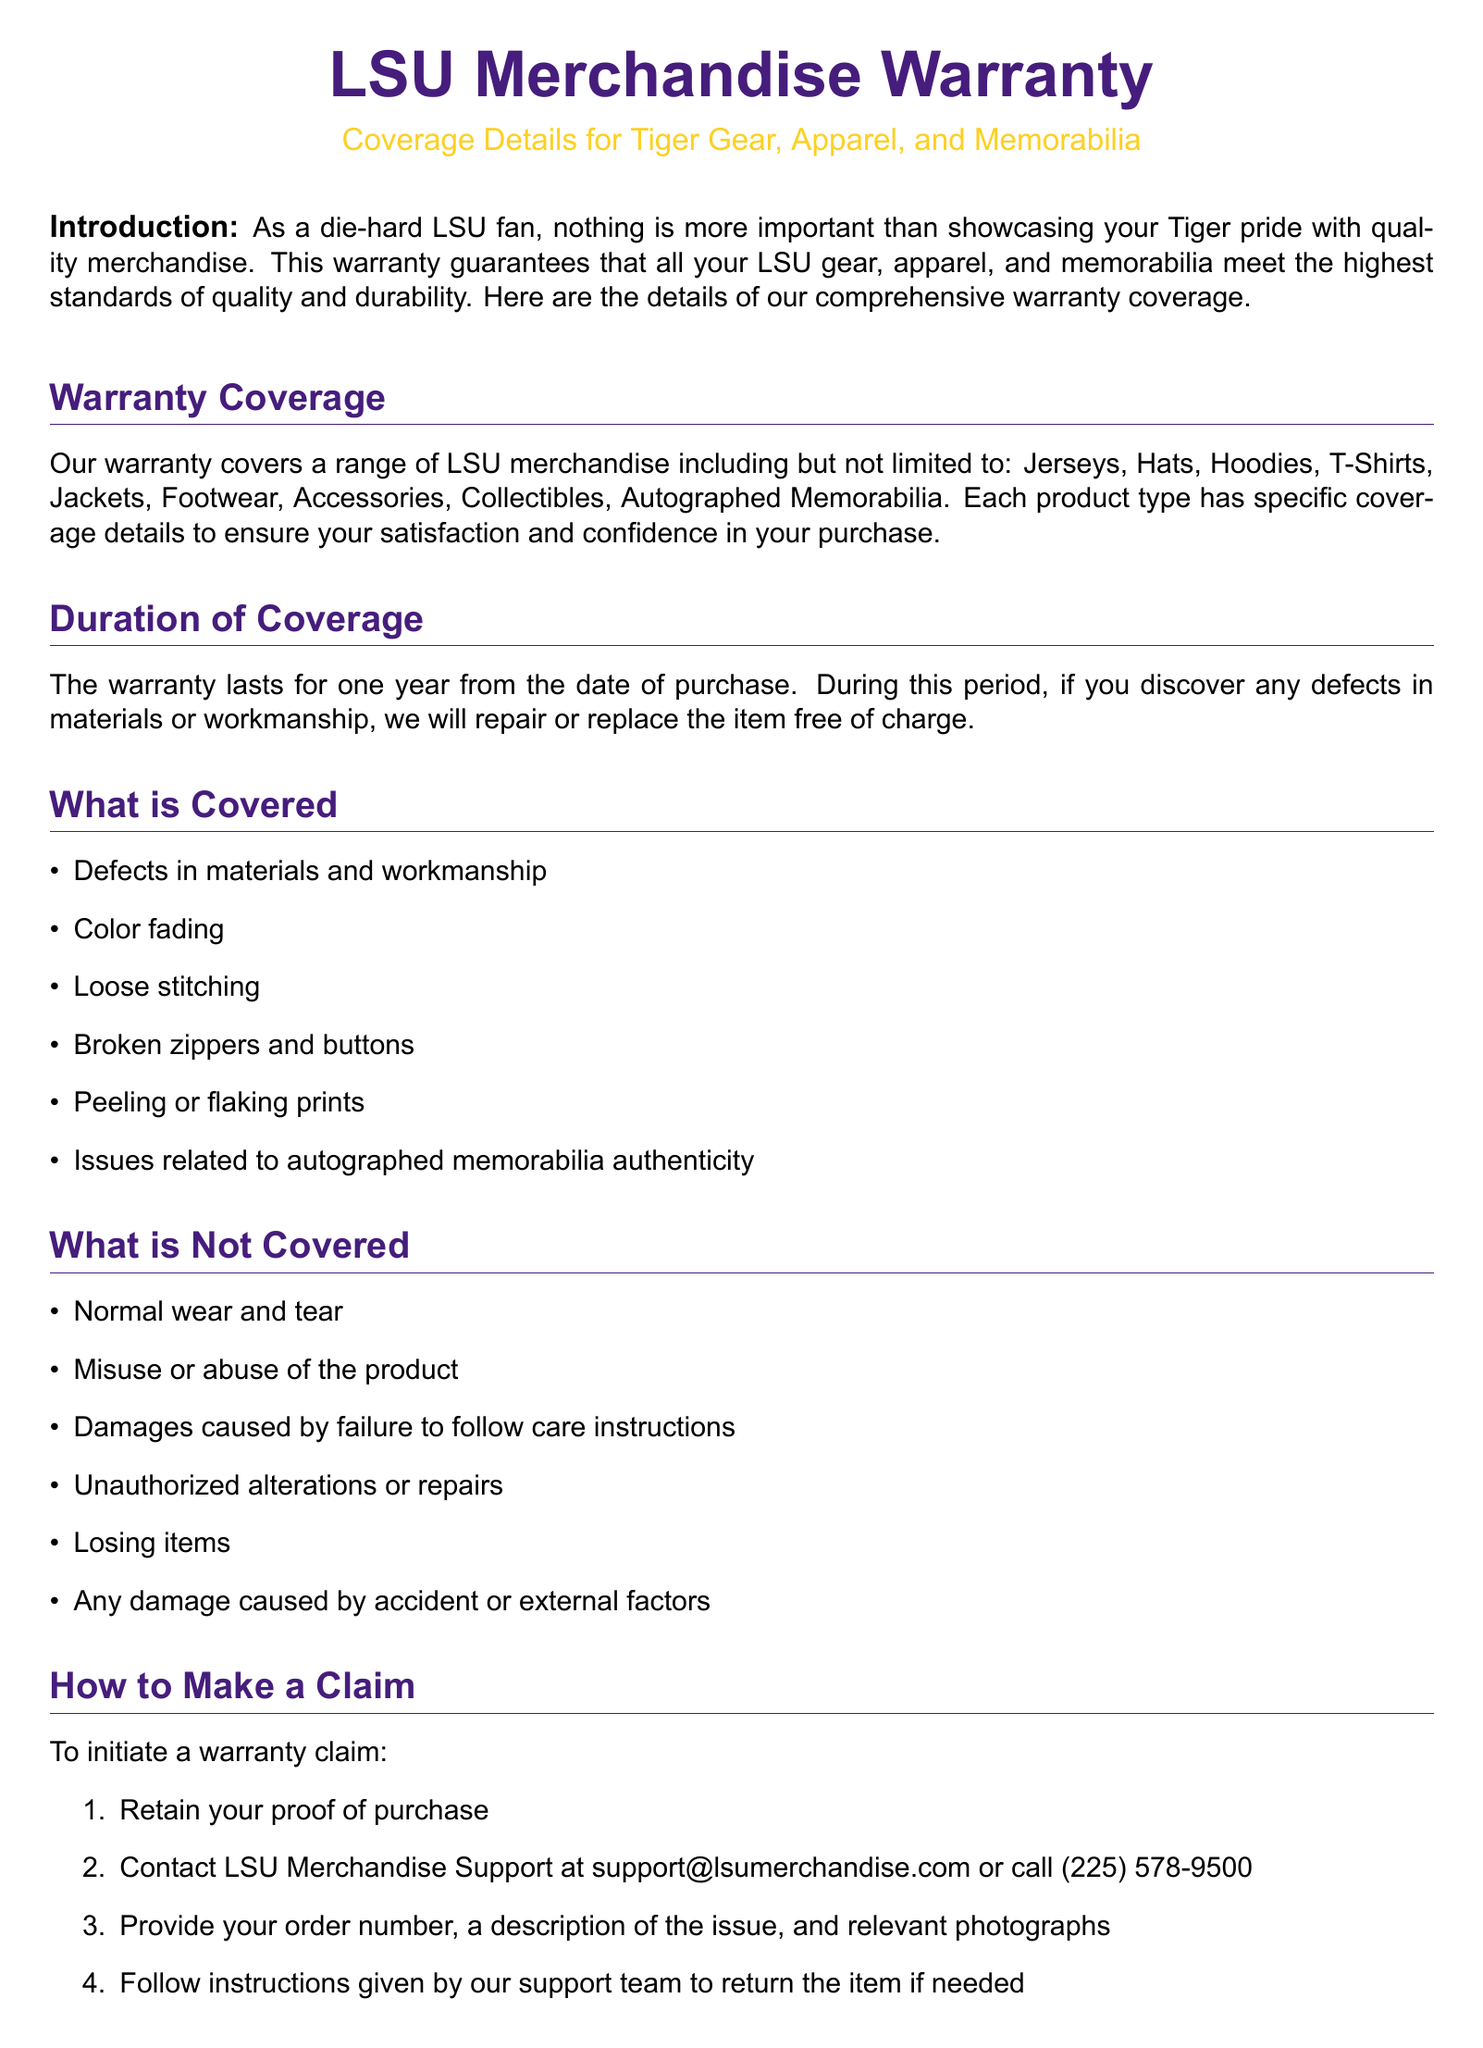What is the duration of coverage? The duration of the warranty coverage lasts for one year from the date of purchase.
Answer: One year What defects are covered under the warranty? The warranty covers defects in materials and workmanship, color fading, loose stitching, broken zippers and buttons, peeling or flaking prints, and issues related to autographed memorabilia authenticity.
Answer: Defects in materials and workmanship What is not covered by the warranty? The warranty does not cover normal wear and tear, misuse, damages from not following care instructions, unauthorized alterations, losing items, or damage from accidents.
Answer: Normal wear and tear How to initiate a warranty claim? To initiate a warranty claim, you need to retain your proof of purchase and contact LSU Merchandise Support.
Answer: Retain proof of purchase and contact support What is the turnaround time for warranty claims? The typical turnaround time for warranty claims is within 21 business days of receiving the returned item.
Answer: 21 business days Who do you contact for warranty support? You can contact LSU Merchandise Support at support@lsumerchandise.com or call (225) 578-9500.
Answer: support@lsumerchandise.com What type of merchandise does the warranty cover? The warranty covers jerseys, hats, hoodies, T-shirts, jackets, footwear, accessories, collectibles, and autographed memorabilia.
Answer: Jerseys, hats, hoodies, T-shirts, jackets, footwear, accessories, collectibles, autographed memorabilia What should you provide when making a claim? When making a claim, you should provide your order number, a description of the issue, and relevant photographs.
Answer: Order number, description, photographs 